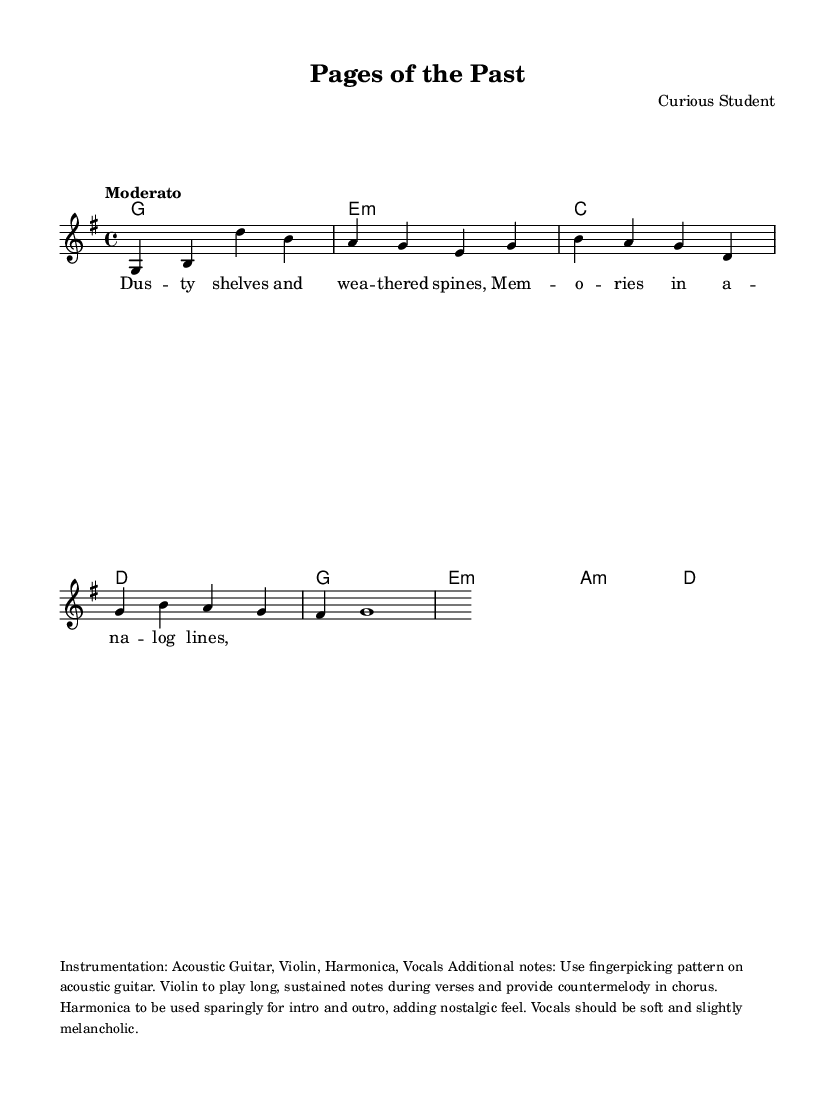What is the key signature of this music? The key signature is G major, indicated by one sharp (F#). It can be determined by looking for any sharps or flats at the beginning of the staff, which denote the key of the piece.
Answer: G major What is the time signature of this piece? The time signature is 4/4, which is indicated at the beginning of the score. It shows that there are four beats in each measure and that the quarter note gets one beat.
Answer: 4/4 What is the tempo marking of the music? The tempo marking is "Moderato," which is indicated at the beginning of the score. It suggests a moderate speed for the performance of the piece.
Answer: Moderato How many measures are in the melody section? The melody section contains eight measures. This can be counted by looking at the bar lines, which separate each measure.
Answer: 8 What type of chords are used in the harmonies? The harmonies consist of major and minor chords. This is evident as the piece lists chords like G major, E minor, and A minor, which are typical chord types used in folk music.
Answer: Major and minor How is the instrumentation specified for this song? The instrumentation includes Acoustic Guitar, Violin, Harmonica, and Vocals, as detailed in the markings below the sheet music. These instruments are specifically noted for their roles and character in the piece.
Answer: Acoustic Guitar, Violin, Harmonica, Vocals What mood is suggested by the lyrics provided in the verse? The mood suggested is nostalgic and melancholic. This can be inferred from words like "dusty" and "weathered," which evoke a sense of longing for the past.
Answer: Nostalgic and melancholic 